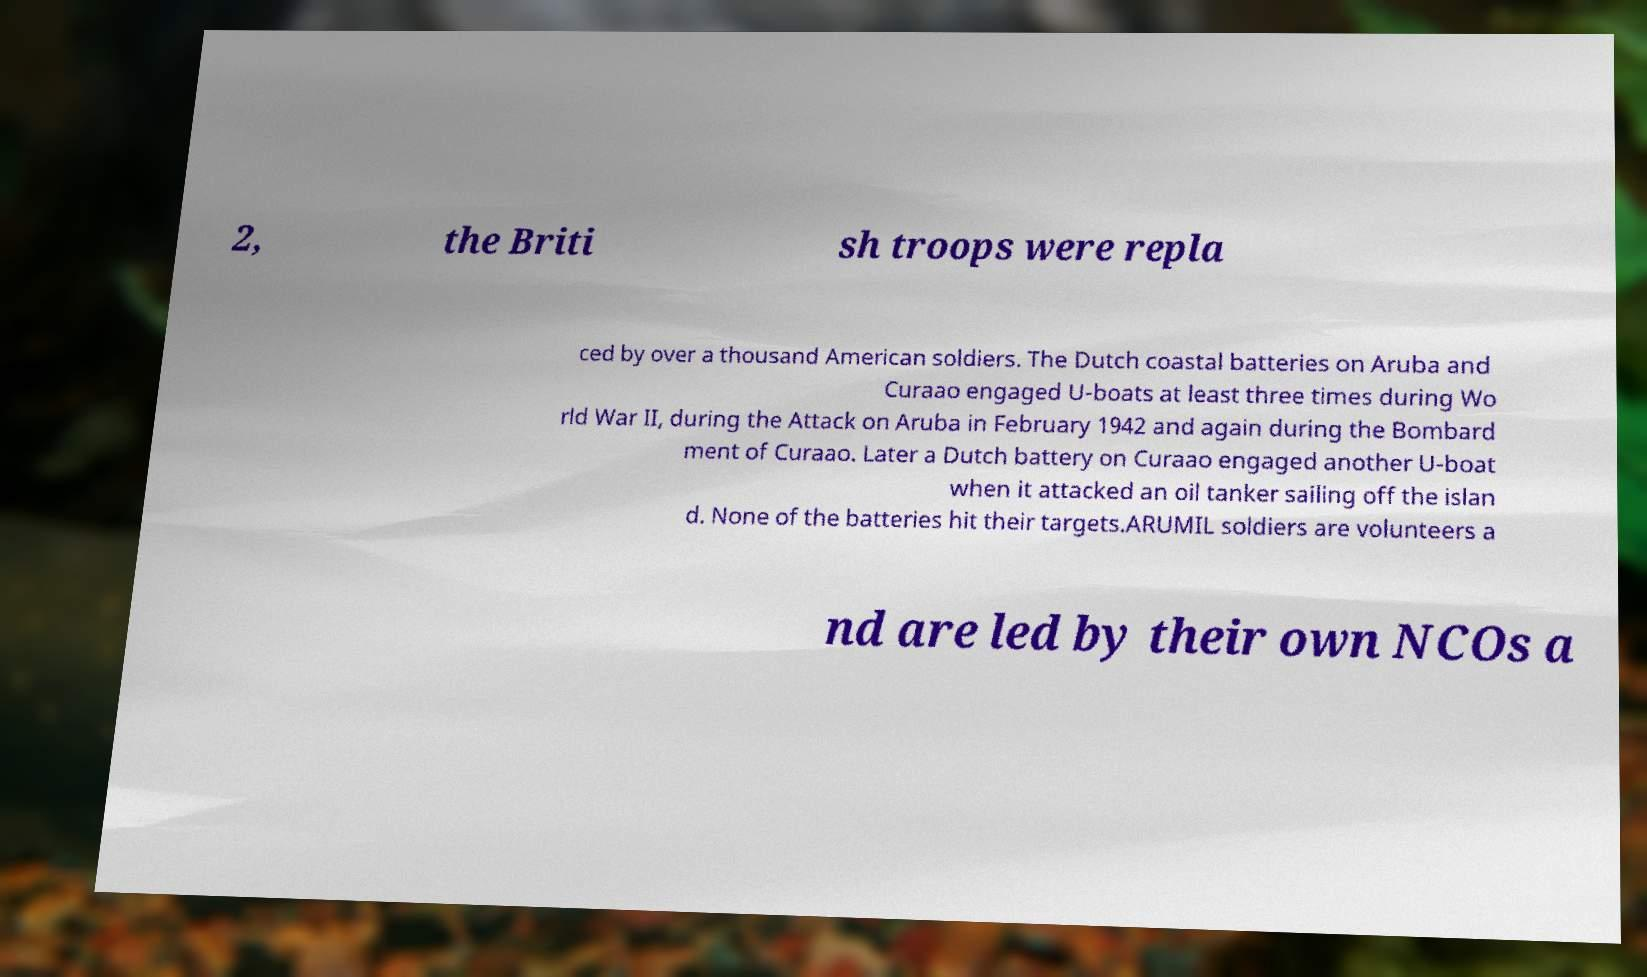Could you assist in decoding the text presented in this image and type it out clearly? 2, the Briti sh troops were repla ced by over a thousand American soldiers. The Dutch coastal batteries on Aruba and Curaao engaged U-boats at least three times during Wo rld War II, during the Attack on Aruba in February 1942 and again during the Bombard ment of Curaao. Later a Dutch battery on Curaao engaged another U-boat when it attacked an oil tanker sailing off the islan d. None of the batteries hit their targets.ARUMIL soldiers are volunteers a nd are led by their own NCOs a 